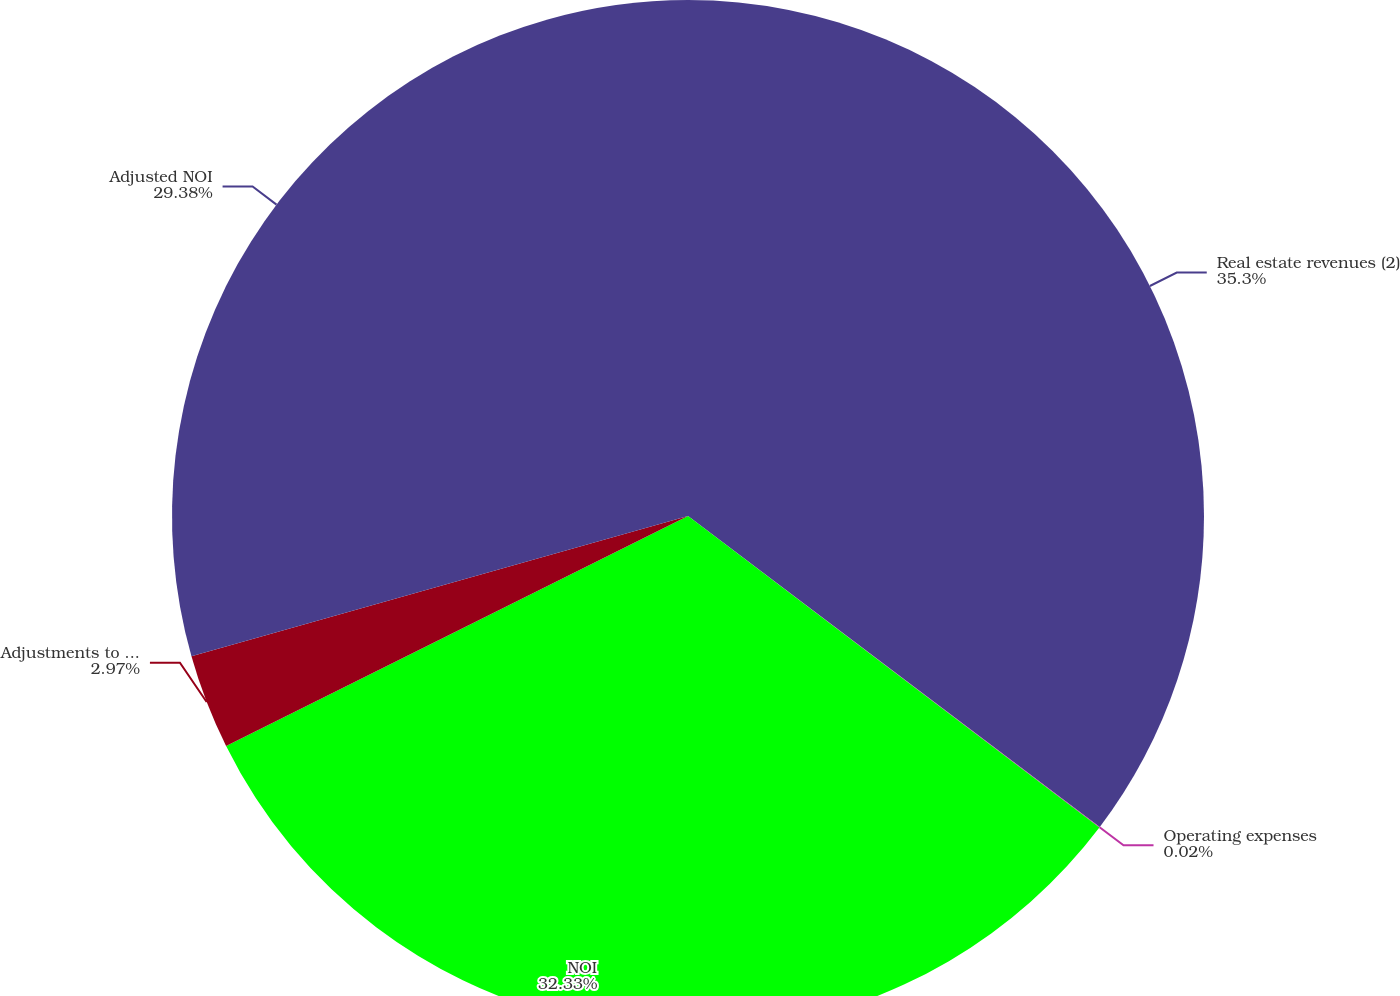Convert chart. <chart><loc_0><loc_0><loc_500><loc_500><pie_chart><fcel>Real estate revenues (2)<fcel>Operating expenses<fcel>NOI<fcel>Adjustments to NOI<fcel>Adjusted NOI<nl><fcel>35.29%<fcel>0.02%<fcel>32.33%<fcel>2.97%<fcel>29.38%<nl></chart> 